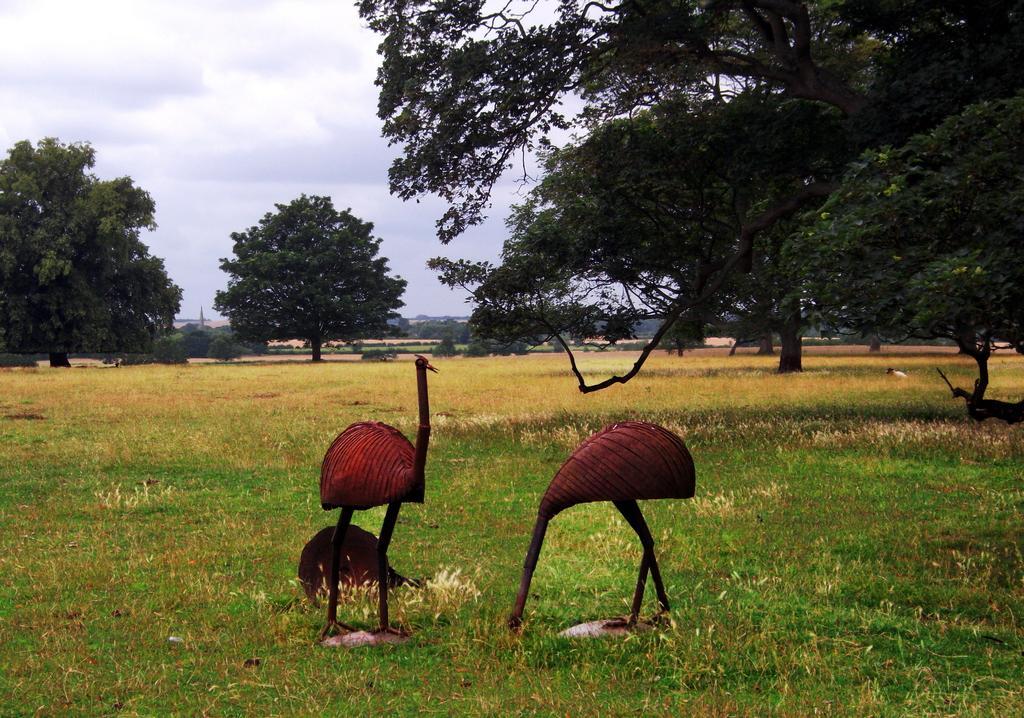Could you give a brief overview of what you see in this image? There are two birds on the ground near grass on the ground. In the background, there are trees and plants on the ground and there are clouds in the sky. 